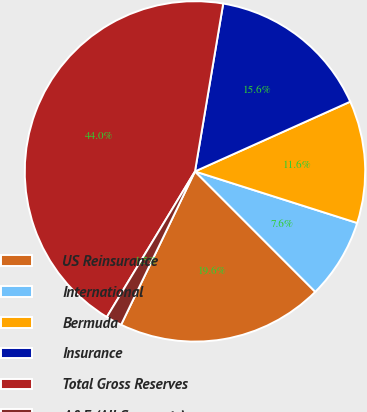Convert chart. <chart><loc_0><loc_0><loc_500><loc_500><pie_chart><fcel>US Reinsurance<fcel>International<fcel>Bermuda<fcel>Insurance<fcel>Total Gross Reserves<fcel>A&E (All Segments)<nl><fcel>19.64%<fcel>7.61%<fcel>11.62%<fcel>15.63%<fcel>43.99%<fcel>1.52%<nl></chart> 